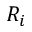Convert formula to latex. <formula><loc_0><loc_0><loc_500><loc_500>R _ { i }</formula> 